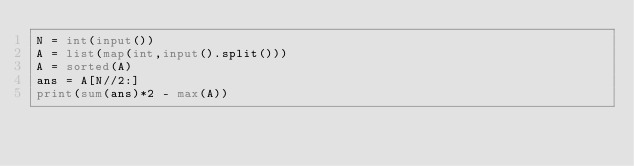Convert code to text. <code><loc_0><loc_0><loc_500><loc_500><_Python_>N = int(input())
A = list(map(int,input().split()))
A = sorted(A)
ans = A[N//2:]
print(sum(ans)*2 - max(A))</code> 